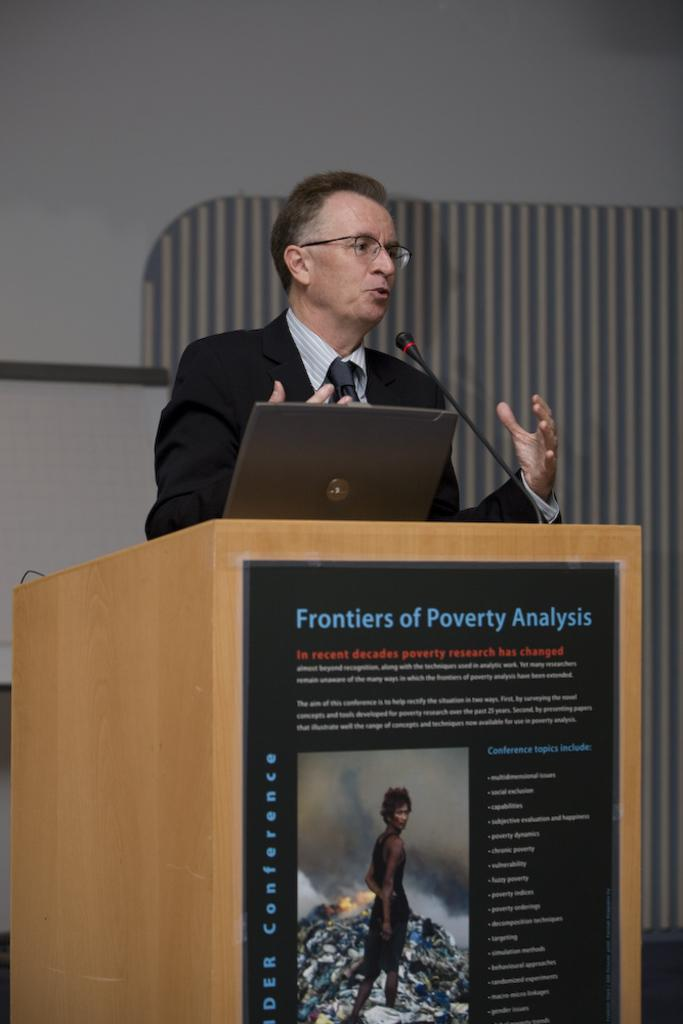<image>
Render a clear and concise summary of the photo. A guy talking about poverty with a laptop besides him. 